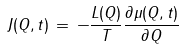<formula> <loc_0><loc_0><loc_500><loc_500>J ( Q , t ) \, = \, - \frac { L ( Q ) } { T } \frac { \partial \mu ( Q , t ) } { \partial Q }</formula> 